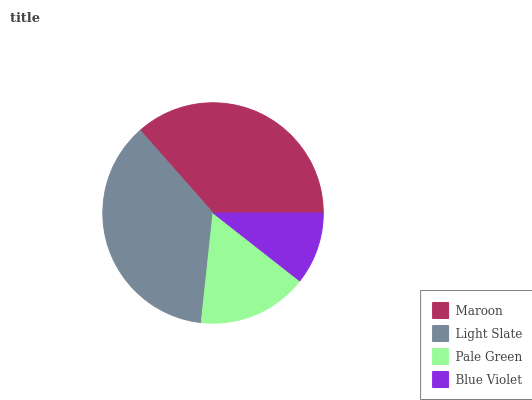Is Blue Violet the minimum?
Answer yes or no. Yes. Is Light Slate the maximum?
Answer yes or no. Yes. Is Pale Green the minimum?
Answer yes or no. No. Is Pale Green the maximum?
Answer yes or no. No. Is Light Slate greater than Pale Green?
Answer yes or no. Yes. Is Pale Green less than Light Slate?
Answer yes or no. Yes. Is Pale Green greater than Light Slate?
Answer yes or no. No. Is Light Slate less than Pale Green?
Answer yes or no. No. Is Maroon the high median?
Answer yes or no. Yes. Is Pale Green the low median?
Answer yes or no. Yes. Is Blue Violet the high median?
Answer yes or no. No. Is Maroon the low median?
Answer yes or no. No. 